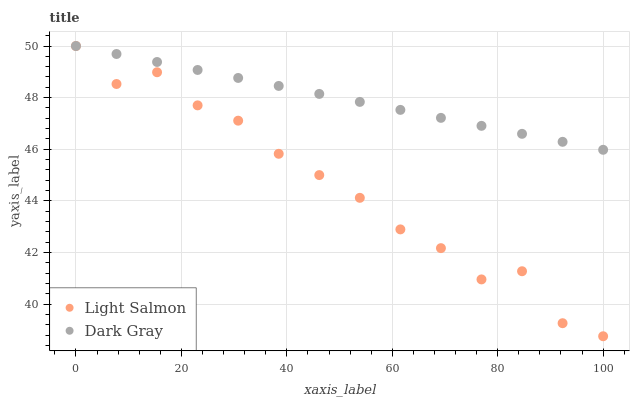Does Light Salmon have the minimum area under the curve?
Answer yes or no. Yes. Does Dark Gray have the maximum area under the curve?
Answer yes or no. Yes. Does Light Salmon have the maximum area under the curve?
Answer yes or no. No. Is Dark Gray the smoothest?
Answer yes or no. Yes. Is Light Salmon the roughest?
Answer yes or no. Yes. Is Light Salmon the smoothest?
Answer yes or no. No. Does Light Salmon have the lowest value?
Answer yes or no. Yes. Does Light Salmon have the highest value?
Answer yes or no. Yes. Does Dark Gray intersect Light Salmon?
Answer yes or no. Yes. Is Dark Gray less than Light Salmon?
Answer yes or no. No. Is Dark Gray greater than Light Salmon?
Answer yes or no. No. 